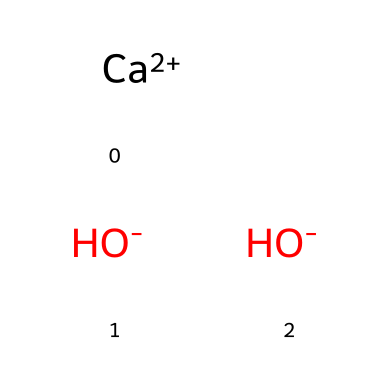What is the molecular formula of this compound? The SMILES representation indicates one calcium atom (Ca) and two hydroxide ions (OH). The molecular formula combines these elements, resulting in Ca(OH)2.
Answer: Ca(OH)2 How many hydroxide ions are present in this chemical? The structure displays two hydroxide ions (OH-) connected to the calcium ion (Ca++), indicating there are two.
Answer: 2 What is the overall charge of this compound? The calcium ion has a +2 charge, while the two hydroxide ions each have a -1 charge, resulting in a total charge of 0 (since +2 - 1 - 1 = 0).
Answer: 0 What type of base is calcium hydroxide classified as? Calcium hydroxide is a strong base due to its complete dissociation in water into calcium and hydroxide ions, which increase the pH significantly.
Answer: strong base How does calcium hydroxide react with acids? As a base, calcium hydroxide neutralizes acids by reacting with hydrogen ions (H+) from the acids, forming water and a salt. This characteristic is typical of bases.
Answer: neutralization reaction What is the role of calcium hydroxide in agricultural applications? Calcium hydroxide is primarily used to increase soil pH, reduce acidity, and improve nutrient availability for crops, enhancing agricultural productivity.
Answer: soil amendment 